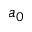Convert formula to latex. <formula><loc_0><loc_0><loc_500><loc_500>a _ { 0 }</formula> 